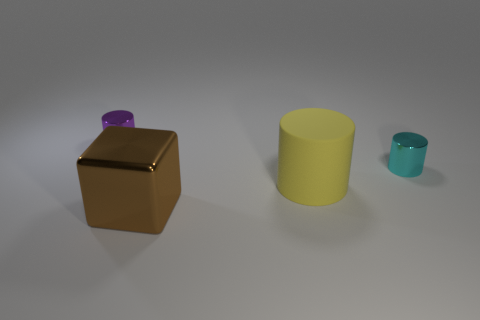Is there any other thing that is the same shape as the brown metallic object?
Your answer should be compact. No. What size is the cyan object?
Offer a terse response. Small. What is the color of the other small object that is the same material as the small cyan object?
Make the answer very short. Purple. What number of cylinders have the same material as the brown cube?
Offer a very short reply. 2. There is a metal cylinder that is on the right side of the small thing that is on the left side of the small cyan metal thing; what color is it?
Offer a terse response. Cyan. The matte cylinder that is the same size as the brown metallic object is what color?
Offer a terse response. Yellow. Are there any small purple things of the same shape as the yellow thing?
Your response must be concise. Yes. The purple metal object has what shape?
Give a very brief answer. Cylinder. Is the number of metal things in front of the large yellow thing greater than the number of large shiny cubes behind the brown cube?
Your answer should be very brief. Yes. What number of other objects are the same size as the purple metallic cylinder?
Your answer should be compact. 1. 